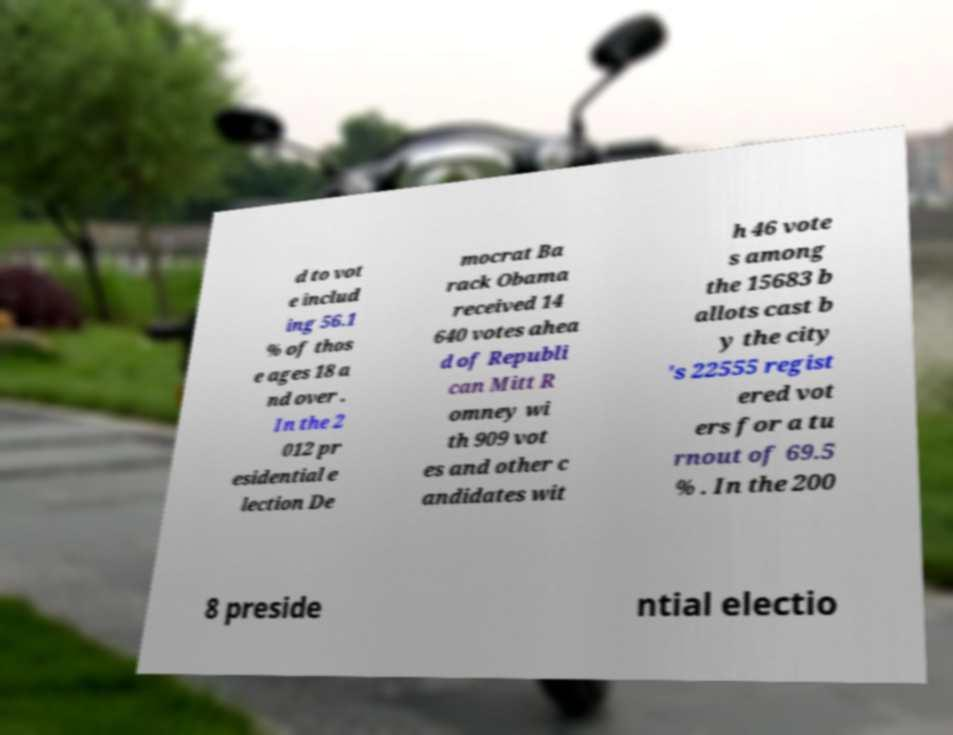For documentation purposes, I need the text within this image transcribed. Could you provide that? d to vot e includ ing 56.1 % of thos e ages 18 a nd over . In the 2 012 pr esidential e lection De mocrat Ba rack Obama received 14 640 votes ahea d of Republi can Mitt R omney wi th 909 vot es and other c andidates wit h 46 vote s among the 15683 b allots cast b y the city 's 22555 regist ered vot ers for a tu rnout of 69.5 % . In the 200 8 preside ntial electio 